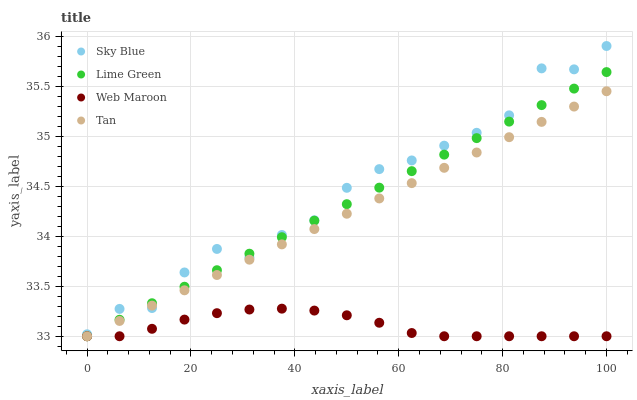Does Web Maroon have the minimum area under the curve?
Answer yes or no. Yes. Does Sky Blue have the maximum area under the curve?
Answer yes or no. Yes. Does Tan have the minimum area under the curve?
Answer yes or no. No. Does Tan have the maximum area under the curve?
Answer yes or no. No. Is Lime Green the smoothest?
Answer yes or no. Yes. Is Sky Blue the roughest?
Answer yes or no. Yes. Is Tan the smoothest?
Answer yes or no. No. Is Tan the roughest?
Answer yes or no. No. Does Tan have the lowest value?
Answer yes or no. Yes. Does Sky Blue have the highest value?
Answer yes or no. Yes. Does Tan have the highest value?
Answer yes or no. No. Is Web Maroon less than Sky Blue?
Answer yes or no. Yes. Is Sky Blue greater than Web Maroon?
Answer yes or no. Yes. Does Lime Green intersect Web Maroon?
Answer yes or no. Yes. Is Lime Green less than Web Maroon?
Answer yes or no. No. Is Lime Green greater than Web Maroon?
Answer yes or no. No. Does Web Maroon intersect Sky Blue?
Answer yes or no. No. 